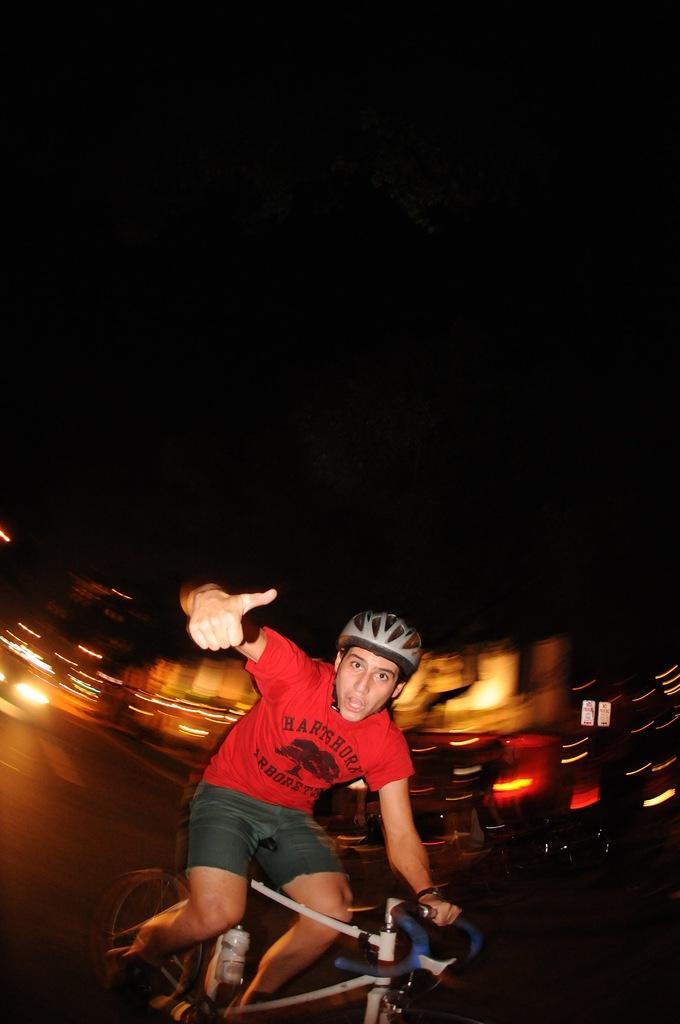Could you give a brief overview of what you see in this image? As we can see in the image there is a man wearing helmet, red color t shirt and riding bicycle. 